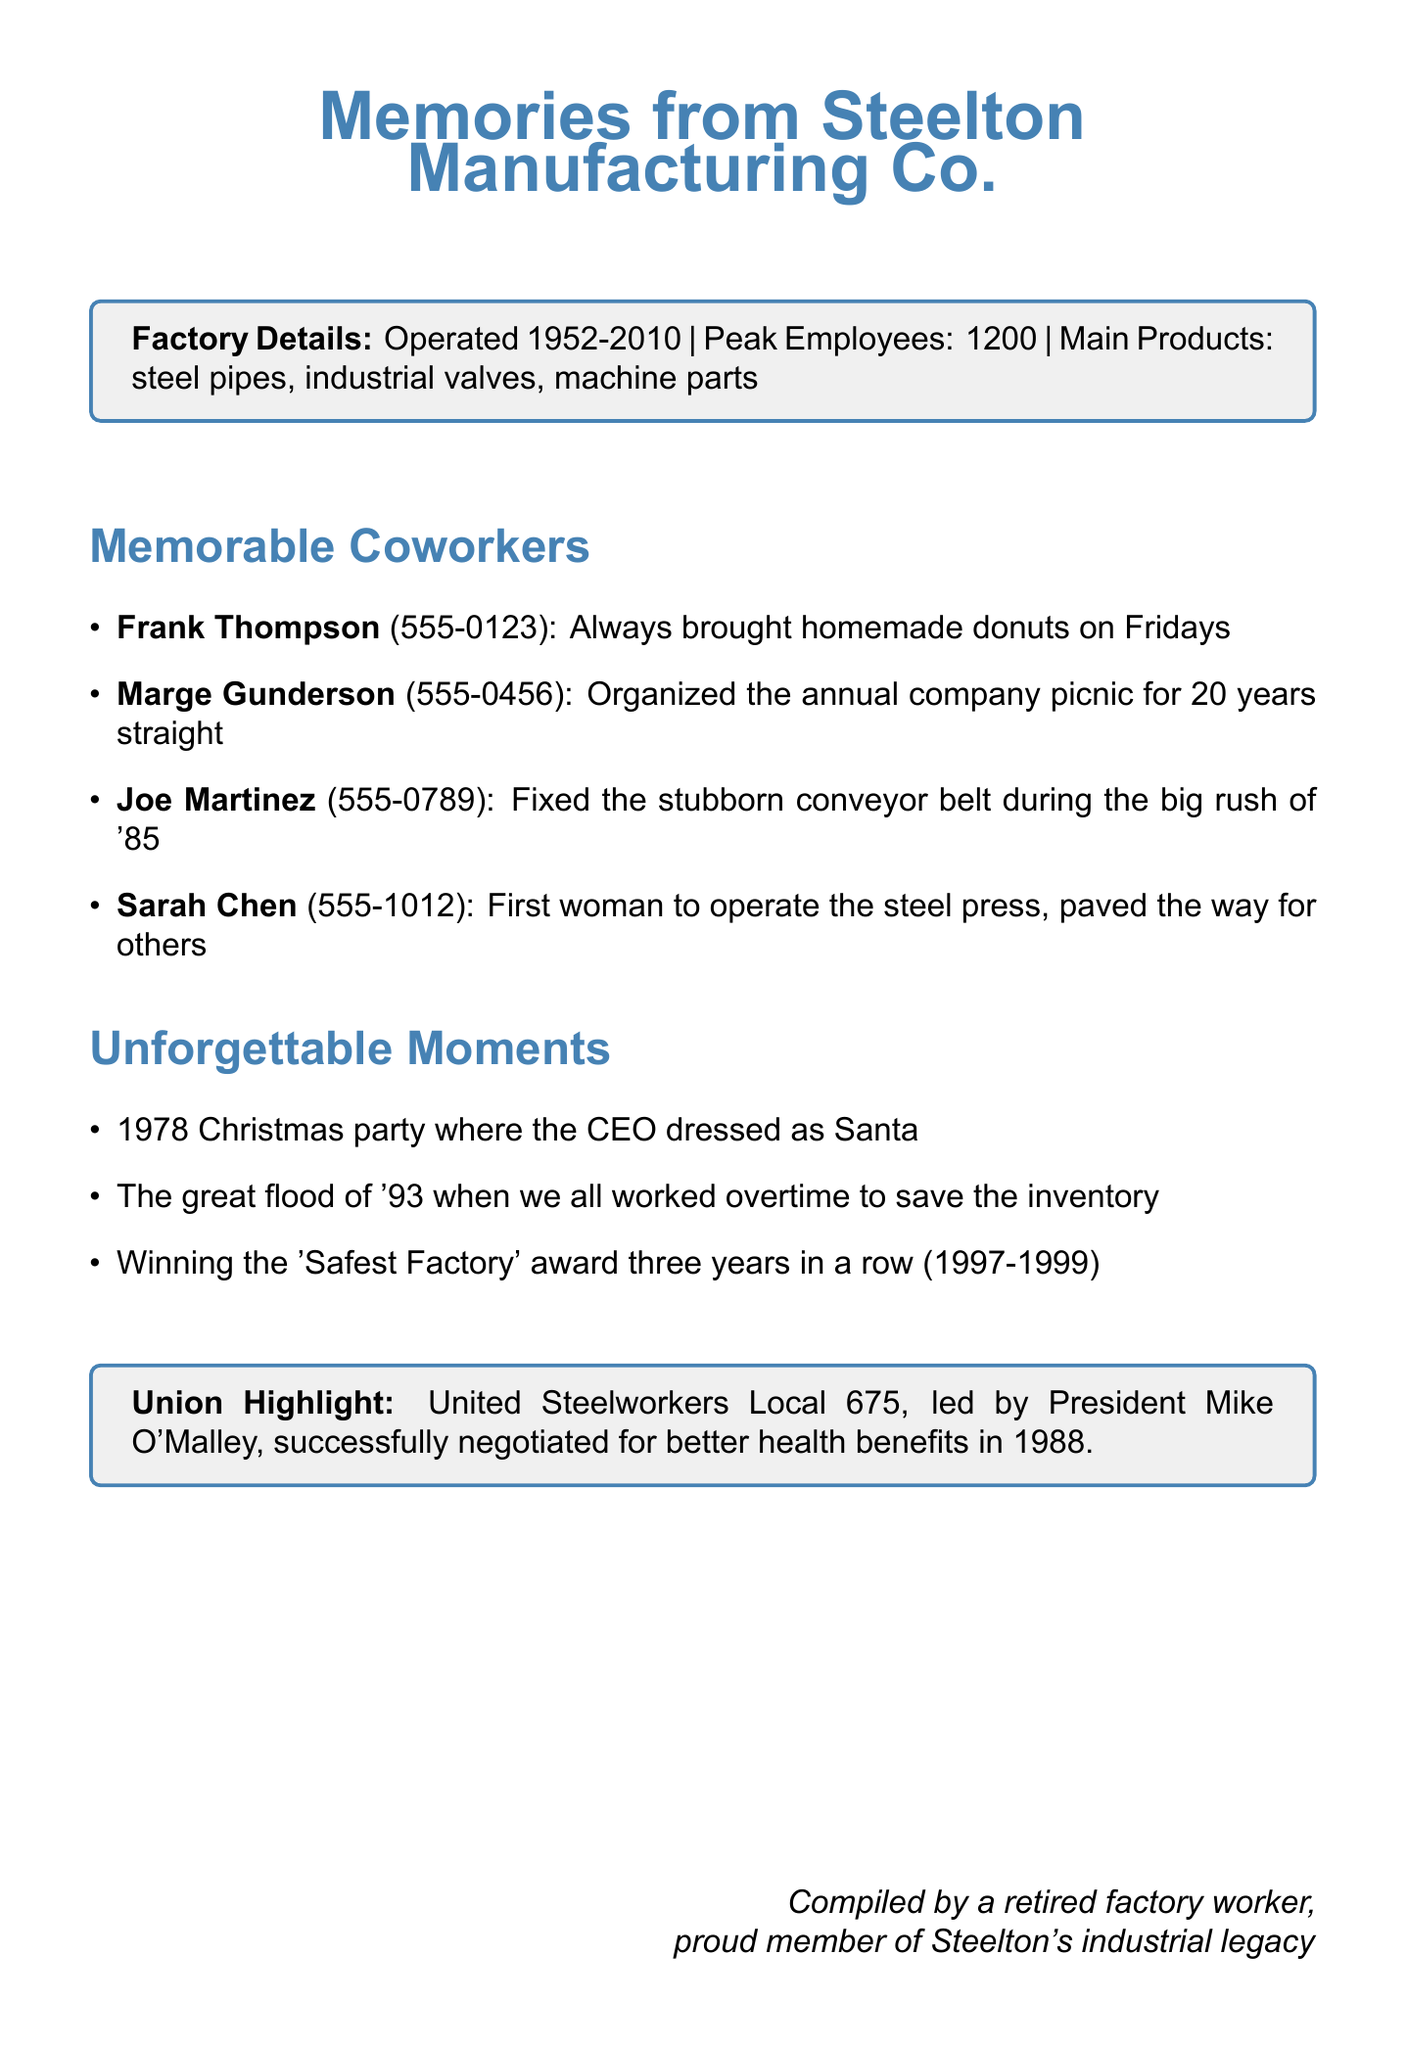What were the years the factory operated? The years of operation for Steelton Manufacturing Co. are listed in the document.
Answer: 1952-2010 Who was the first woman to operate the steel press? Sarah Chen is mentioned as the first woman to operate the steel press in the document.
Answer: Sarah Chen What is the phone number of Joe Martinez? Joe Martinez's contact information includes his phone number in the document.
Answer: 555-0789 How many employees did the factory peak at? The document states the peak number of employees at Steelton Manufacturing Co.
Answer: 1200 Which event did the CEO dress as Santa? The specific Christmas party is mentioned where the CEO dressed as Santa in the document.
Answer: 1978 Christmas party What was the significant action taken by the union in 1988? The union's significant action is described in the document, highlighting an important achievement.
Answer: Better health benefits How many years did Marge Gunderson organize the company picnic? The document indicates the duration Marge Gunderson organized the annual picnic.
Answer: 20 years What award did the factory win three years in a row? The document includes the specific award won by the factory for multiple years.
Answer: Safest Factory 